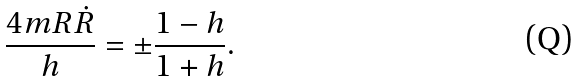<formula> <loc_0><loc_0><loc_500><loc_500>\frac { 4 m R \dot { R } } { h } = \pm \frac { 1 - h } { 1 + h } .</formula> 